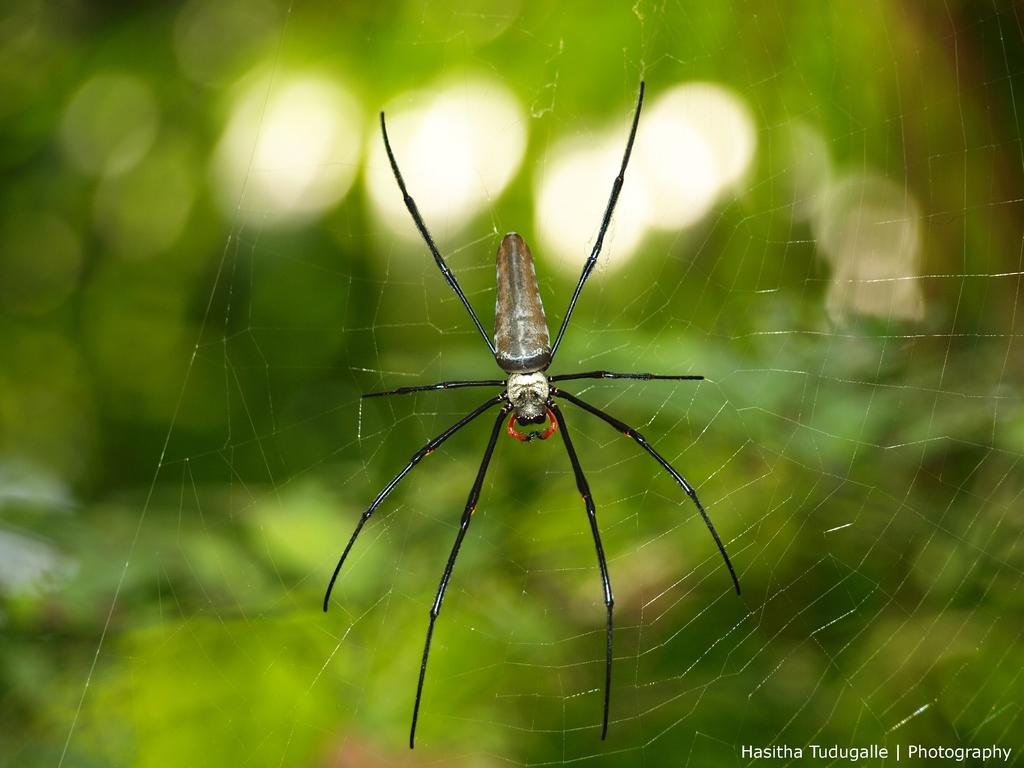What is present in the image? There is a spider and a web in the image. Can you describe the web in the image? The web is likely created by the spider for catching prey. What type of milk is being delivered by the van in the image? There is no van or milk present in the image; it only features a spider and a web. 